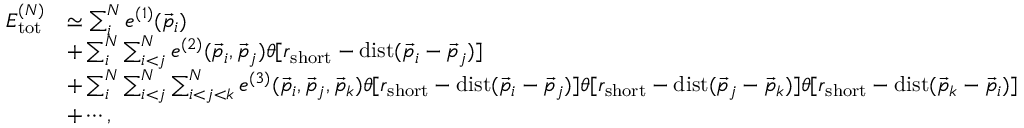Convert formula to latex. <formula><loc_0><loc_0><loc_500><loc_500>\begin{array} { r l } { E _ { t o t } ^ { ( N ) } } & { \simeq \sum _ { i } ^ { N } e ^ { ( 1 ) } ( \vec { p } _ { i } ) } \\ & { + \sum _ { i } ^ { N } \sum _ { i < j } ^ { N } e ^ { ( 2 ) } ( \vec { p } _ { i } , \vec { p } _ { j } ) \theta [ r _ { s h o r t } - d i s t ( \vec { p } _ { i } - \vec { p } _ { j } ) ] } \\ & { + \sum _ { i } ^ { N } \sum _ { i < j } ^ { N } \sum _ { i < j < k } ^ { N } e ^ { ( 3 ) } ( \vec { p } _ { i } , \vec { p } _ { j } , \vec { p } _ { k } ) \theta [ r _ { s h o r t } - d i s t ( \vec { p } _ { i } - \vec { p } _ { j } ) ] \theta [ r _ { s h o r t } - d i s t ( \vec { p } _ { j } - \vec { p } _ { k } ) ] \theta [ r _ { s h o r t } - d i s t ( \vec { p } _ { k } - \vec { p } _ { i } ) ] } \\ & { + \cdots , } \end{array}</formula> 